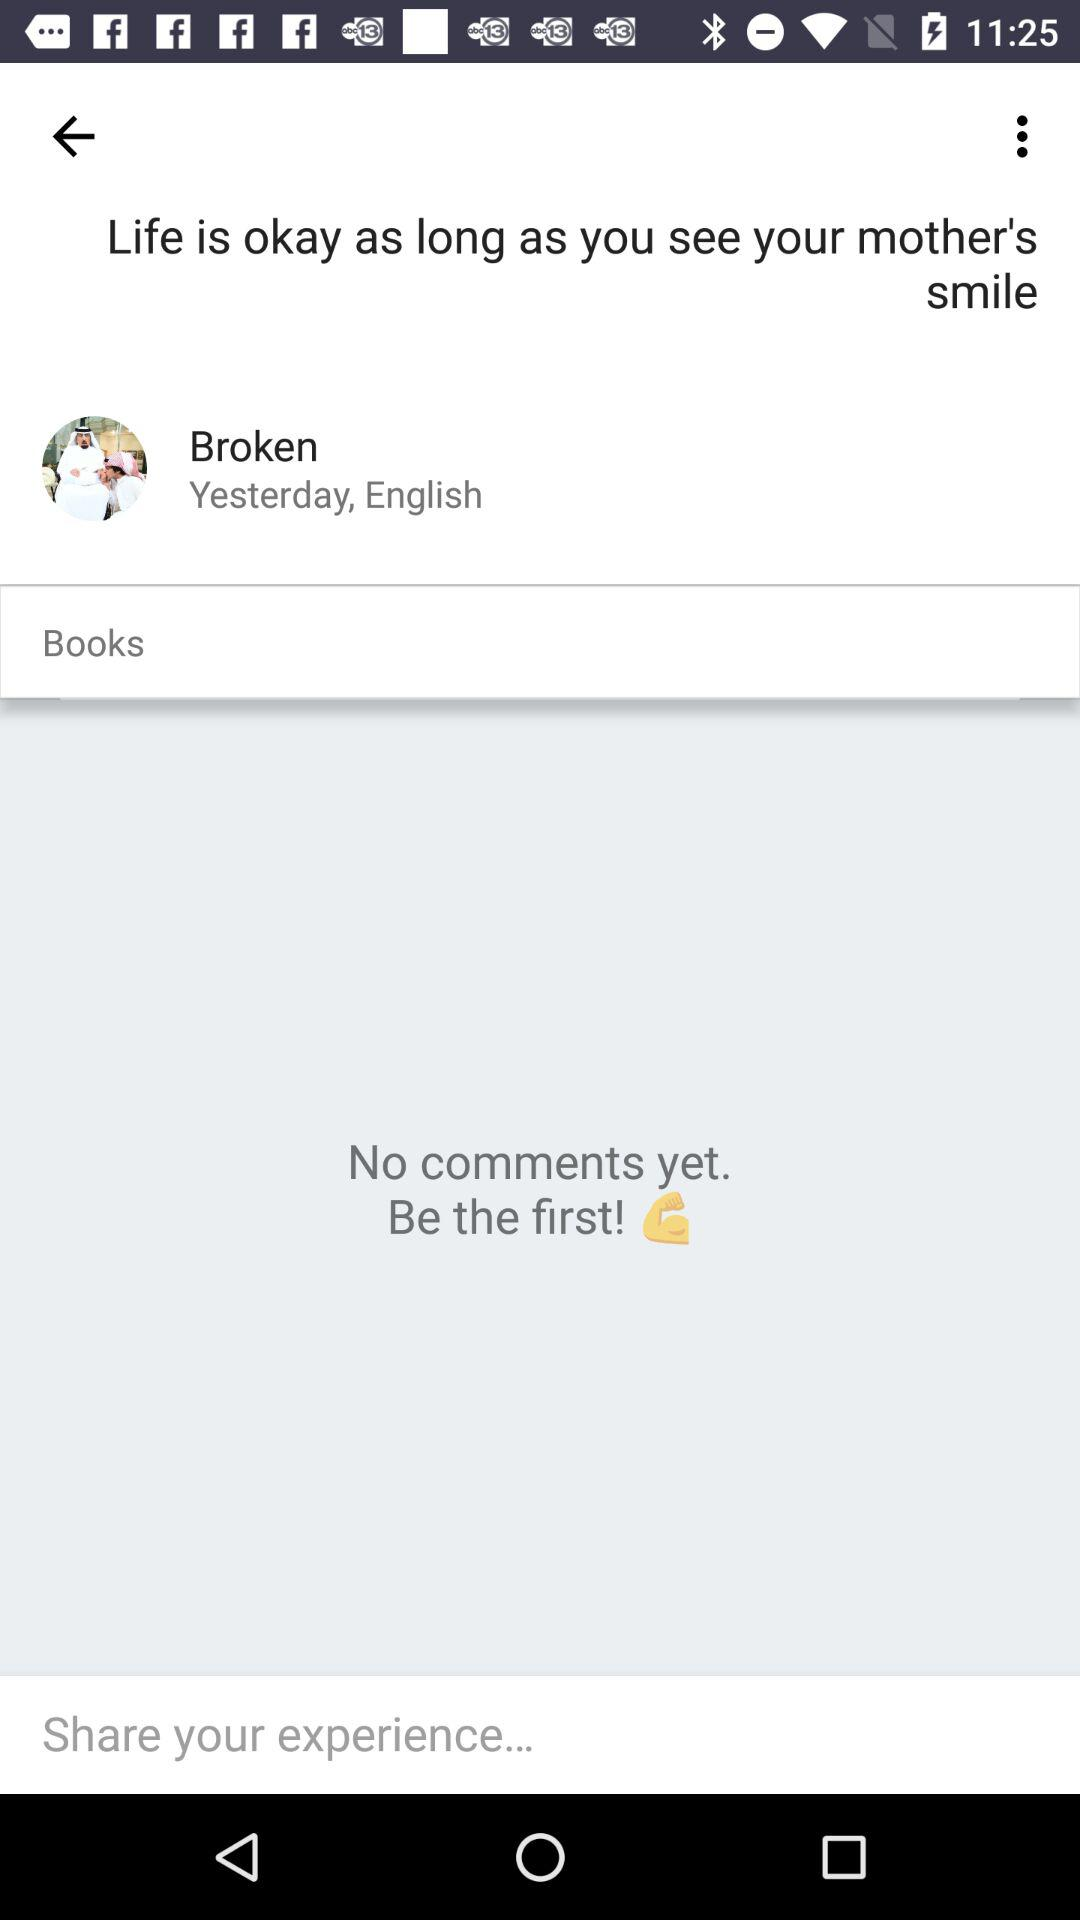What is the language of Broken? The language is English. 